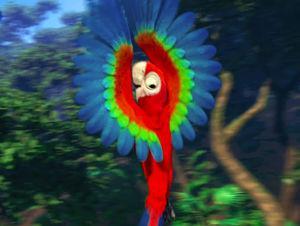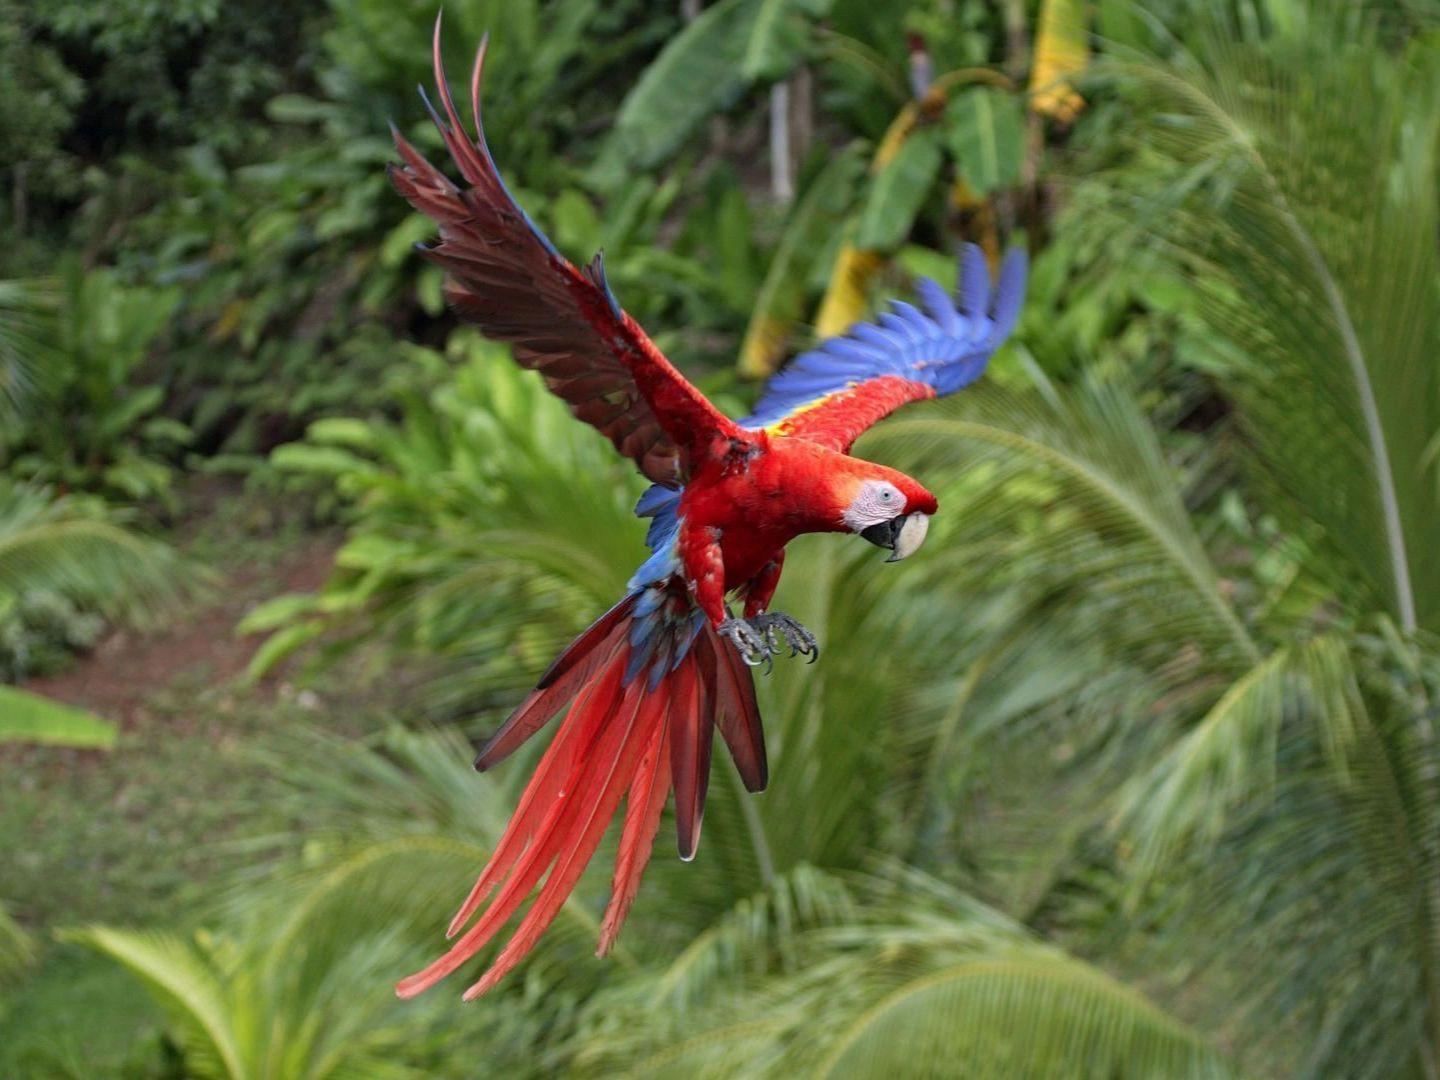The first image is the image on the left, the second image is the image on the right. For the images displayed, is the sentence "At least one of the images has two birds standing on the same branch." factually correct? Answer yes or no. No. The first image is the image on the left, the second image is the image on the right. Considering the images on both sides, is "The parrot in the right image is flying." valid? Answer yes or no. Yes. The first image is the image on the left, the second image is the image on the right. Analyze the images presented: Is the assertion "In the paired images, only parrots with spread wings are shown." valid? Answer yes or no. Yes. 